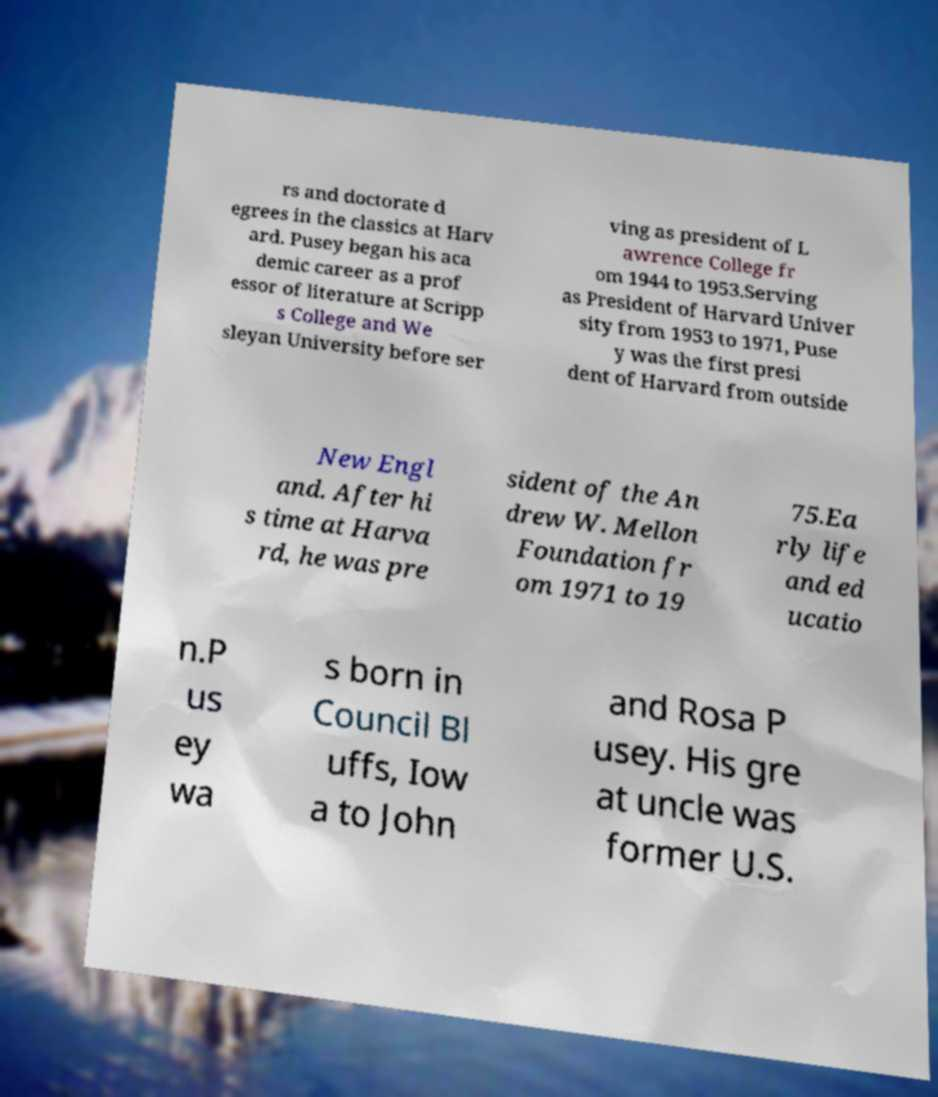Can you read and provide the text displayed in the image?This photo seems to have some interesting text. Can you extract and type it out for me? rs and doctorate d egrees in the classics at Harv ard. Pusey began his aca demic career as a prof essor of literature at Scripp s College and We sleyan University before ser ving as president of L awrence College fr om 1944 to 1953.Serving as President of Harvard Univer sity from 1953 to 1971, Puse y was the first presi dent of Harvard from outside New Engl and. After hi s time at Harva rd, he was pre sident of the An drew W. Mellon Foundation fr om 1971 to 19 75.Ea rly life and ed ucatio n.P us ey wa s born in Council Bl uffs, Iow a to John and Rosa P usey. His gre at uncle was former U.S. 